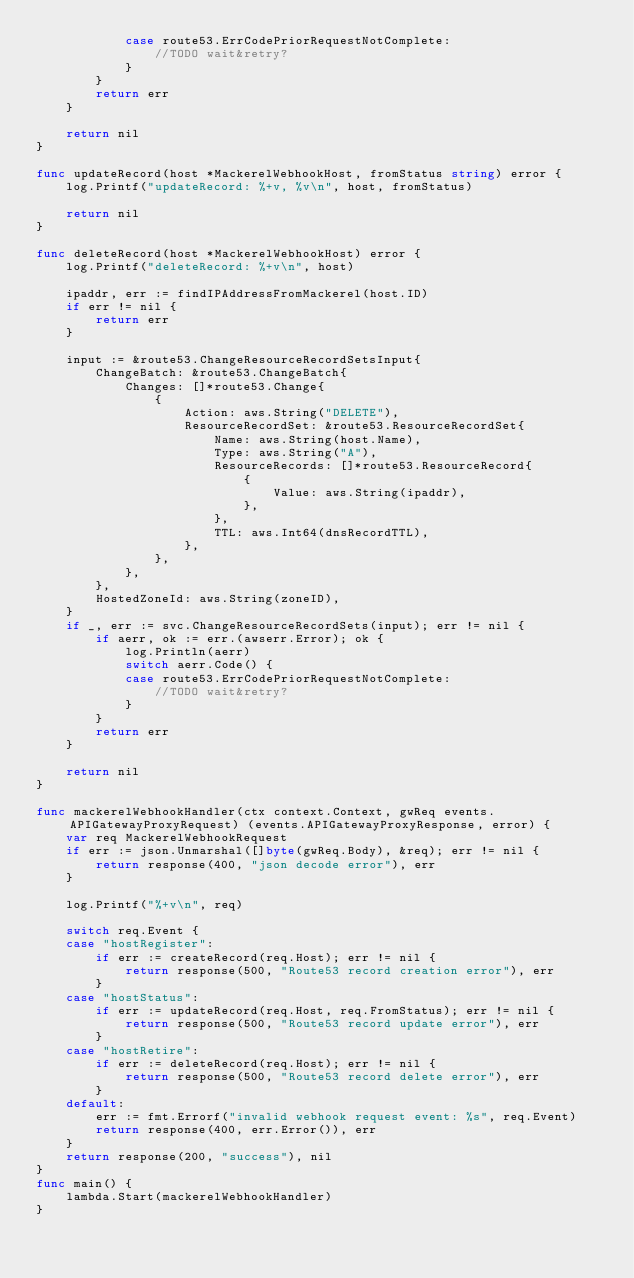<code> <loc_0><loc_0><loc_500><loc_500><_Go_>			case route53.ErrCodePriorRequestNotComplete:
				//TODO wait&retry?
			}
		}
		return err
	}

	return nil
}

func updateRecord(host *MackerelWebhookHost, fromStatus string) error {
	log.Printf("updateRecord: %+v, %v\n", host, fromStatus)

	return nil
}

func deleteRecord(host *MackerelWebhookHost) error {
	log.Printf("deleteRecord: %+v\n", host)

	ipaddr, err := findIPAddressFromMackerel(host.ID)
	if err != nil {
		return err
	}

	input := &route53.ChangeResourceRecordSetsInput{
		ChangeBatch: &route53.ChangeBatch{
			Changes: []*route53.Change{
				{
					Action: aws.String("DELETE"),
					ResourceRecordSet: &route53.ResourceRecordSet{
						Name: aws.String(host.Name),
						Type: aws.String("A"),
						ResourceRecords: []*route53.ResourceRecord{
							{
								Value: aws.String(ipaddr),
							},
						},
						TTL: aws.Int64(dnsRecordTTL),
					},
				},
			},
		},
		HostedZoneId: aws.String(zoneID),
	}
	if _, err := svc.ChangeResourceRecordSets(input); err != nil {
		if aerr, ok := err.(awserr.Error); ok {
			log.Println(aerr)
			switch aerr.Code() {
			case route53.ErrCodePriorRequestNotComplete:
				//TODO wait&retry?
			}
		}
		return err
	}

	return nil
}

func mackerelWebhookHandler(ctx context.Context, gwReq events.APIGatewayProxyRequest) (events.APIGatewayProxyResponse, error) {
	var req MackerelWebhookRequest
	if err := json.Unmarshal([]byte(gwReq.Body), &req); err != nil {
		return response(400, "json decode error"), err
	}

	log.Printf("%+v\n", req)

	switch req.Event {
	case "hostRegister":
		if err := createRecord(req.Host); err != nil {
			return response(500, "Route53 record creation error"), err
		}
	case "hostStatus":
		if err := updateRecord(req.Host, req.FromStatus); err != nil {
			return response(500, "Route53 record update error"), err
		}
	case "hostRetire":
		if err := deleteRecord(req.Host); err != nil {
			return response(500, "Route53 record delete error"), err
		}
	default:
		err := fmt.Errorf("invalid webhook request event: %s", req.Event)
		return response(400, err.Error()), err
	}
	return response(200, "success"), nil
}
func main() {
	lambda.Start(mackerelWebhookHandler)
}
</code> 